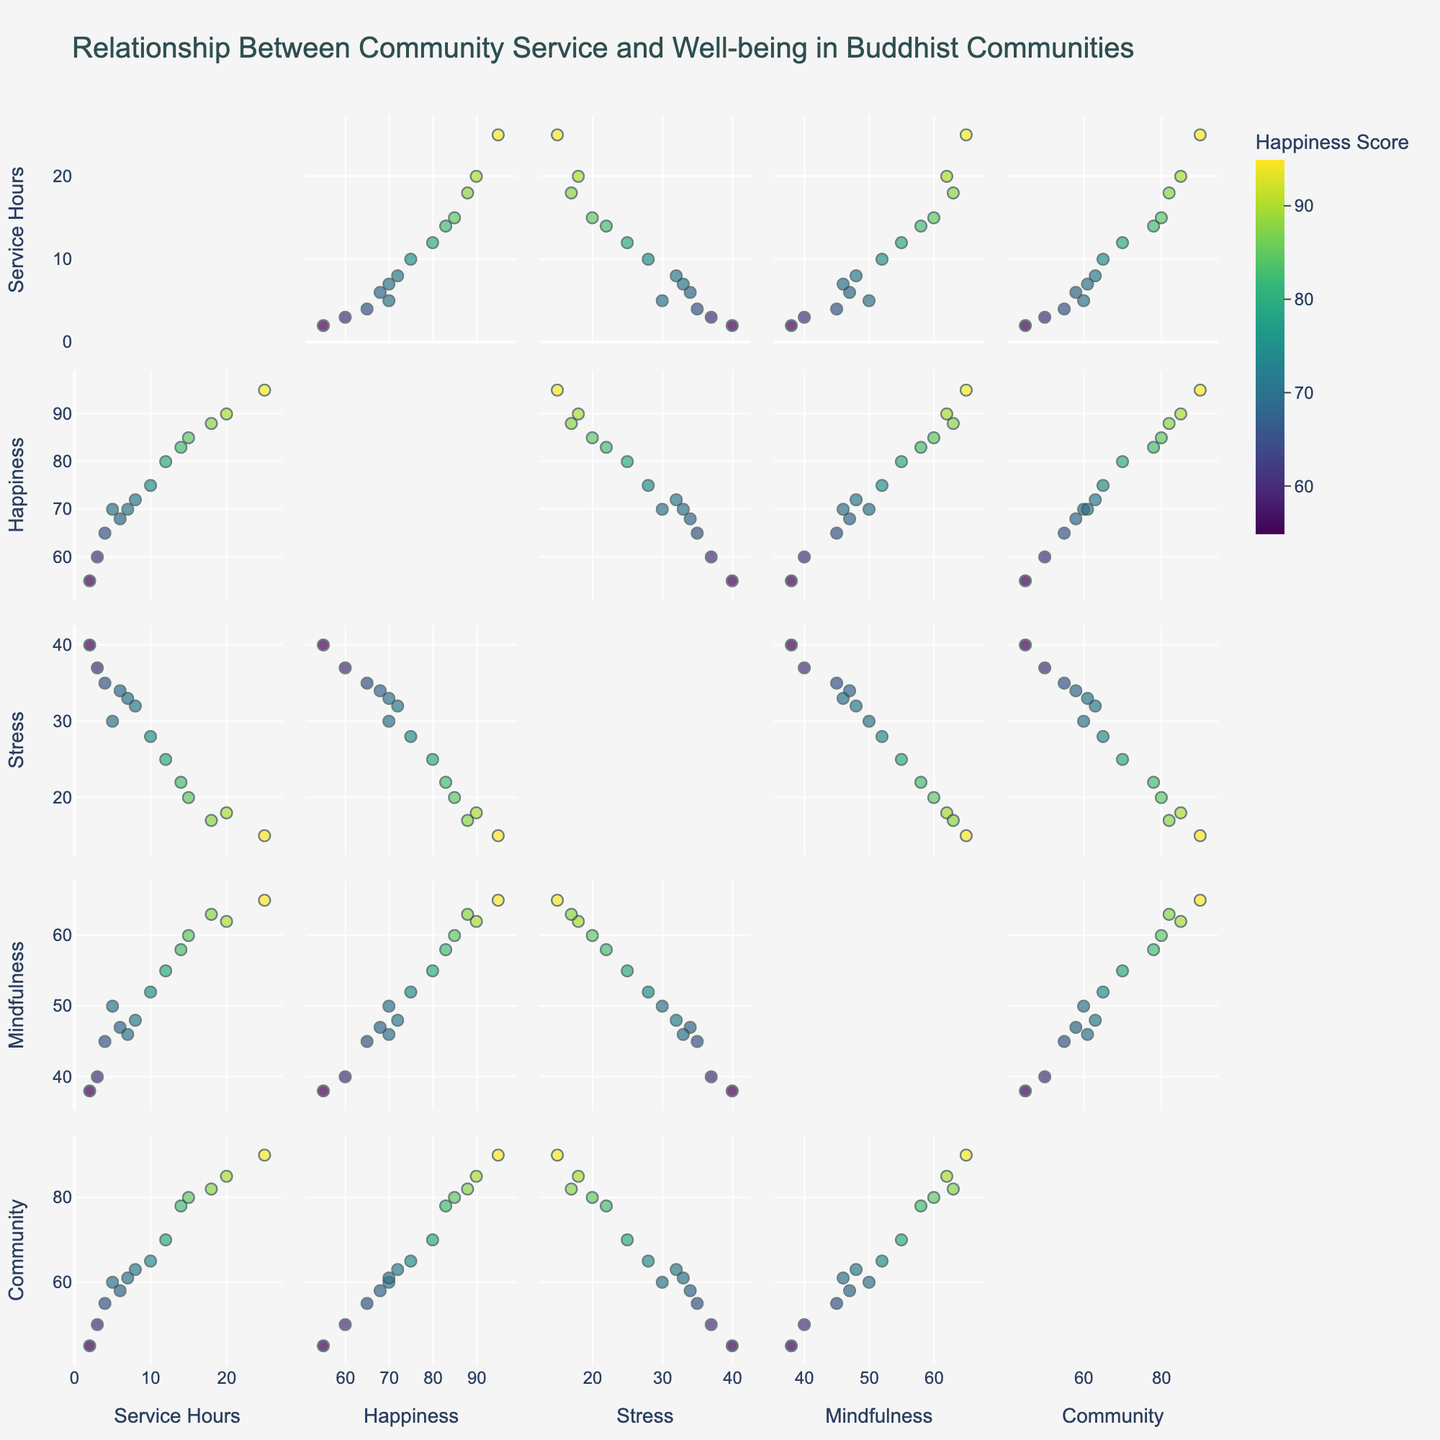What is the title of the scatter plot matrix? The title of the figure is displayed at the top, usually in larger and bold text. It summarizes the main theme of the plot.
Answer: Relationship Between Community Service and Well-being in Buddhist Communities How many dimensions are displayed in the scatter plot matrix? The dimensions are labeled on the axes for each scatter plot in the matrix. By counting these labels, you can determine the number of dimensions.
Answer: 5 Which variable is used to color the data points in the scatter plot matrix? The variable used for coloring is indicated in the color legend, which should be labeled accordingly. In this case, it is "Happiness Score."
Answer: Happiness Score What range of "Community Service Hours" have the highest "Happiness Score"? By looking at the sub-plot that maps "Community Service Hours" against "Happiness Score," note the data points with the highest coloring (as indicated in the color legend).
Answer: 20-25 Do higher "Mindfulness Scores" correlate with lower "Stress Scores"? Find the subplot that plots "Mindfulness Scores" against "Stress Scores" and observe the trend of the data points. A negative correlation will show as a downward trend.
Answer: Yes Is there a noticeable trend between "Community Service Hours" and "Sense Of Community"? Look at the scatter plot for "Community Service Hours" vs. "Sense Of Community." A noticeable upward or downward slope indicates a trend.
Answer: Yes, positive trend Which scatter plot shows the strongest positive correlation? Examine the correlation trends within each subplot. The strongest positive correlation is where data points are closest to forming a straight line with a positive slope.
Answer: Community Service Hours vs. Happiness Score How does the "Stress Score" change with increasing "Community Service Hours"? Check the subplot mapping "Community Service Hours" vs. "Stress Score" to see if the plot trends upward, downward, or remains scattered without any visible pattern.
Answer: Decreases What is the relationship between "Happiness Score" and "Sense Of Community"? Find the corresponding scatter plot for "Happiness Score" vs. "Sense Of Community" and observe the trend of data points.
Answer: Positive relationship Out of the variables "Community Service Hours," "Happiness Score," "Stress Score," and "Mindfulness Score," which one shows a clear improvement in "Sense Of Community"? Identify the scatter plot where "Sense Of Community" is plotted against each of the other variables and check for the clearest positive trend.
Answer: Community Service Hours 